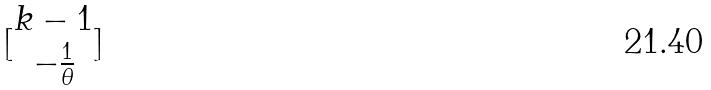<formula> <loc_0><loc_0><loc_500><loc_500>[ \begin{matrix} k - 1 \\ - \frac { 1 } { \theta } \end{matrix} ]</formula> 